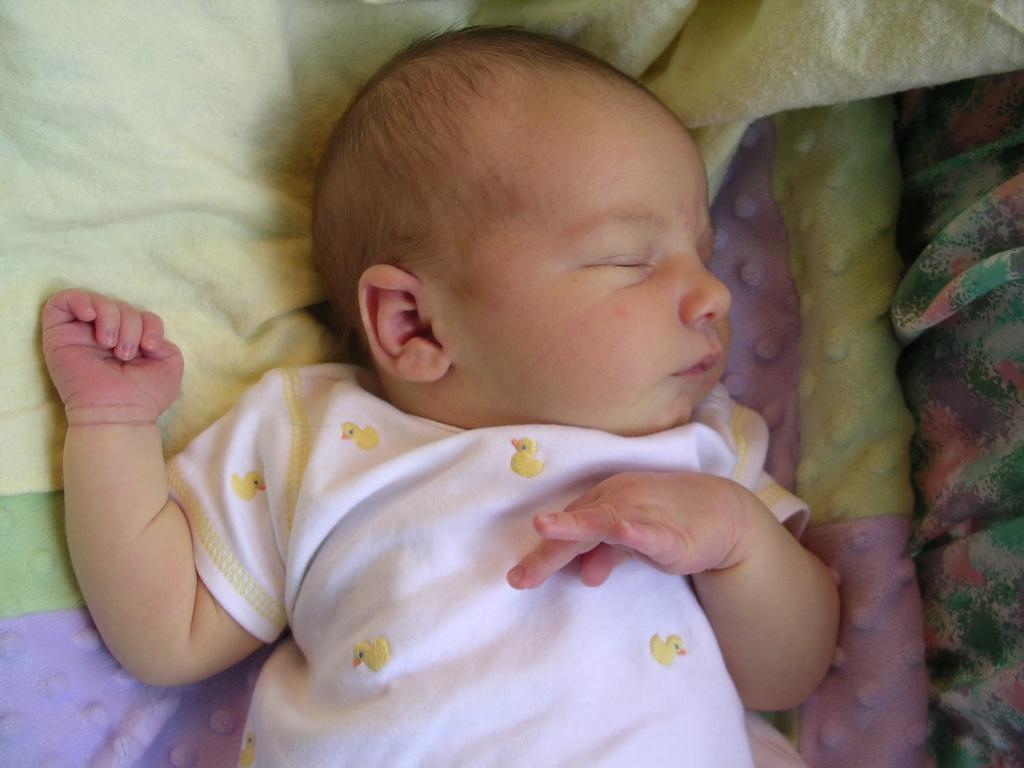How would you summarize this image in a sentence or two? In this image in the center there is one baby sleeping, and in the background there are some blankets. 